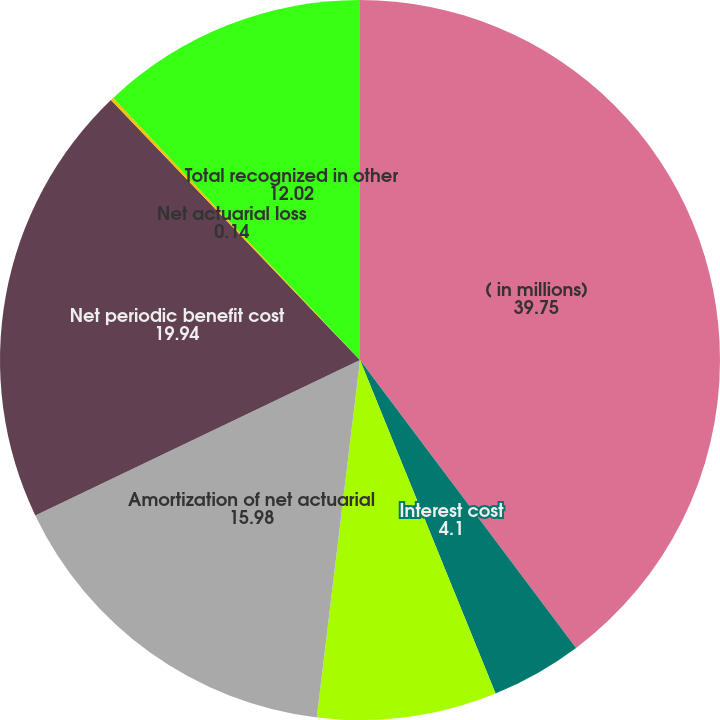Convert chart. <chart><loc_0><loc_0><loc_500><loc_500><pie_chart><fcel>( in millions)<fcel>Interest cost<fcel>Expected return on assets<fcel>Amortization of net actuarial<fcel>Net periodic benefit cost<fcel>Net actuarial loss<fcel>Total recognized in other<nl><fcel>39.75%<fcel>4.1%<fcel>8.06%<fcel>15.98%<fcel>19.94%<fcel>0.14%<fcel>12.02%<nl></chart> 